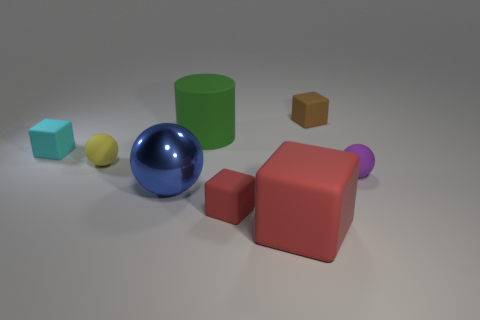Subtract all small rubber spheres. How many spheres are left? 1 Subtract all yellow balls. How many balls are left? 2 Subtract all balls. How many objects are left? 5 Subtract 3 balls. How many balls are left? 0 Add 7 big blue rubber blocks. How many big blue rubber blocks exist? 7 Add 2 tiny rubber spheres. How many objects exist? 10 Subtract 1 green cylinders. How many objects are left? 7 Subtract all purple balls. Subtract all yellow cylinders. How many balls are left? 2 Subtract all gray cylinders. How many blue balls are left? 1 Subtract all tiny purple metallic cubes. Subtract all blue spheres. How many objects are left? 7 